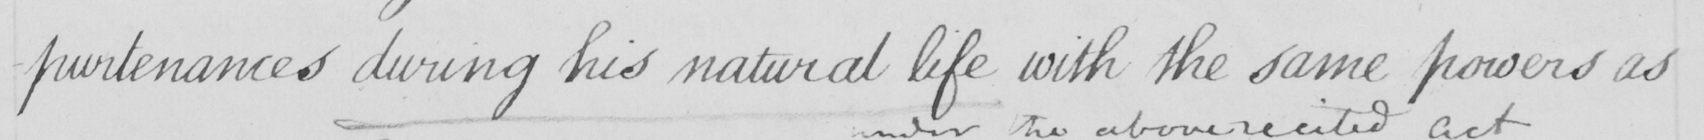What is written in this line of handwriting? -purtenances during his natural life with the same powers as 